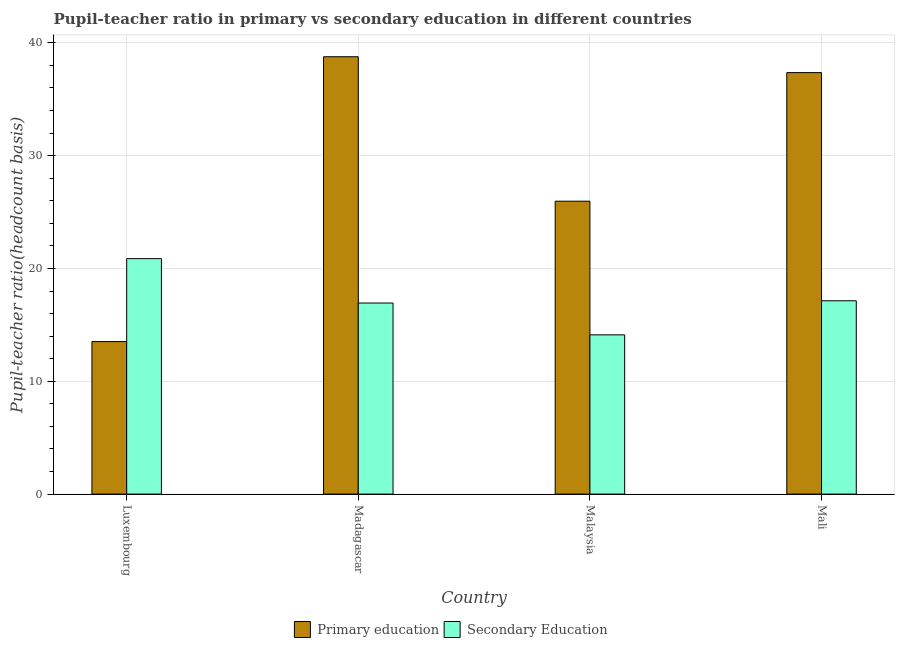How many different coloured bars are there?
Ensure brevity in your answer.  2. How many bars are there on the 1st tick from the right?
Make the answer very short. 2. What is the label of the 4th group of bars from the left?
Give a very brief answer. Mali. What is the pupil teacher ratio on secondary education in Malaysia?
Give a very brief answer. 14.11. Across all countries, what is the maximum pupil teacher ratio on secondary education?
Keep it short and to the point. 20.87. Across all countries, what is the minimum pupil-teacher ratio in primary education?
Give a very brief answer. 13.52. In which country was the pupil-teacher ratio in primary education maximum?
Offer a very short reply. Madagascar. In which country was the pupil-teacher ratio in primary education minimum?
Your answer should be very brief. Luxembourg. What is the total pupil teacher ratio on secondary education in the graph?
Provide a short and direct response. 69.05. What is the difference between the pupil-teacher ratio in primary education in Madagascar and that in Mali?
Provide a short and direct response. 1.41. What is the difference between the pupil teacher ratio on secondary education in Malaysia and the pupil-teacher ratio in primary education in Luxembourg?
Ensure brevity in your answer.  0.59. What is the average pupil-teacher ratio in primary education per country?
Your response must be concise. 28.9. What is the difference between the pupil-teacher ratio in primary education and pupil teacher ratio on secondary education in Madagascar?
Keep it short and to the point. 21.83. What is the ratio of the pupil-teacher ratio in primary education in Luxembourg to that in Mali?
Offer a very short reply. 0.36. Is the difference between the pupil-teacher ratio in primary education in Malaysia and Mali greater than the difference between the pupil teacher ratio on secondary education in Malaysia and Mali?
Ensure brevity in your answer.  No. What is the difference between the highest and the second highest pupil-teacher ratio in primary education?
Provide a succinct answer. 1.41. What is the difference between the highest and the lowest pupil-teacher ratio in primary education?
Provide a succinct answer. 25.24. What does the 2nd bar from the left in Madagascar represents?
Ensure brevity in your answer.  Secondary Education. What does the 1st bar from the right in Madagascar represents?
Your response must be concise. Secondary Education. Are all the bars in the graph horizontal?
Your response must be concise. No. What is the difference between two consecutive major ticks on the Y-axis?
Your answer should be compact. 10. Are the values on the major ticks of Y-axis written in scientific E-notation?
Keep it short and to the point. No. Does the graph contain any zero values?
Offer a terse response. No. Does the graph contain grids?
Make the answer very short. Yes. How are the legend labels stacked?
Ensure brevity in your answer.  Horizontal. What is the title of the graph?
Provide a succinct answer. Pupil-teacher ratio in primary vs secondary education in different countries. Does "Private credit bureau" appear as one of the legend labels in the graph?
Your answer should be compact. No. What is the label or title of the Y-axis?
Your answer should be very brief. Pupil-teacher ratio(headcount basis). What is the Pupil-teacher ratio(headcount basis) of Primary education in Luxembourg?
Offer a very short reply. 13.52. What is the Pupil-teacher ratio(headcount basis) in Secondary Education in Luxembourg?
Provide a succinct answer. 20.87. What is the Pupil-teacher ratio(headcount basis) in Primary education in Madagascar?
Keep it short and to the point. 38.76. What is the Pupil-teacher ratio(headcount basis) in Secondary Education in Madagascar?
Make the answer very short. 16.93. What is the Pupil-teacher ratio(headcount basis) of Primary education in Malaysia?
Ensure brevity in your answer.  25.96. What is the Pupil-teacher ratio(headcount basis) of Secondary Education in Malaysia?
Provide a short and direct response. 14.11. What is the Pupil-teacher ratio(headcount basis) of Primary education in Mali?
Give a very brief answer. 37.36. What is the Pupil-teacher ratio(headcount basis) of Secondary Education in Mali?
Make the answer very short. 17.13. Across all countries, what is the maximum Pupil-teacher ratio(headcount basis) in Primary education?
Your response must be concise. 38.76. Across all countries, what is the maximum Pupil-teacher ratio(headcount basis) of Secondary Education?
Keep it short and to the point. 20.87. Across all countries, what is the minimum Pupil-teacher ratio(headcount basis) of Primary education?
Your answer should be very brief. 13.52. Across all countries, what is the minimum Pupil-teacher ratio(headcount basis) in Secondary Education?
Keep it short and to the point. 14.11. What is the total Pupil-teacher ratio(headcount basis) of Primary education in the graph?
Provide a short and direct response. 115.6. What is the total Pupil-teacher ratio(headcount basis) in Secondary Education in the graph?
Make the answer very short. 69.05. What is the difference between the Pupil-teacher ratio(headcount basis) of Primary education in Luxembourg and that in Madagascar?
Offer a terse response. -25.24. What is the difference between the Pupil-teacher ratio(headcount basis) of Secondary Education in Luxembourg and that in Madagascar?
Offer a very short reply. 3.93. What is the difference between the Pupil-teacher ratio(headcount basis) in Primary education in Luxembourg and that in Malaysia?
Offer a terse response. -12.44. What is the difference between the Pupil-teacher ratio(headcount basis) of Secondary Education in Luxembourg and that in Malaysia?
Provide a succinct answer. 6.76. What is the difference between the Pupil-teacher ratio(headcount basis) in Primary education in Luxembourg and that in Mali?
Make the answer very short. -23.84. What is the difference between the Pupil-teacher ratio(headcount basis) in Secondary Education in Luxembourg and that in Mali?
Offer a very short reply. 3.73. What is the difference between the Pupil-teacher ratio(headcount basis) in Primary education in Madagascar and that in Malaysia?
Offer a very short reply. 12.8. What is the difference between the Pupil-teacher ratio(headcount basis) of Secondary Education in Madagascar and that in Malaysia?
Offer a terse response. 2.82. What is the difference between the Pupil-teacher ratio(headcount basis) in Primary education in Madagascar and that in Mali?
Ensure brevity in your answer.  1.41. What is the difference between the Pupil-teacher ratio(headcount basis) of Secondary Education in Madagascar and that in Mali?
Offer a terse response. -0.2. What is the difference between the Pupil-teacher ratio(headcount basis) in Primary education in Malaysia and that in Mali?
Make the answer very short. -11.39. What is the difference between the Pupil-teacher ratio(headcount basis) of Secondary Education in Malaysia and that in Mali?
Give a very brief answer. -3.02. What is the difference between the Pupil-teacher ratio(headcount basis) of Primary education in Luxembourg and the Pupil-teacher ratio(headcount basis) of Secondary Education in Madagascar?
Offer a terse response. -3.42. What is the difference between the Pupil-teacher ratio(headcount basis) of Primary education in Luxembourg and the Pupil-teacher ratio(headcount basis) of Secondary Education in Malaysia?
Give a very brief answer. -0.59. What is the difference between the Pupil-teacher ratio(headcount basis) of Primary education in Luxembourg and the Pupil-teacher ratio(headcount basis) of Secondary Education in Mali?
Your answer should be very brief. -3.62. What is the difference between the Pupil-teacher ratio(headcount basis) of Primary education in Madagascar and the Pupil-teacher ratio(headcount basis) of Secondary Education in Malaysia?
Offer a terse response. 24.65. What is the difference between the Pupil-teacher ratio(headcount basis) in Primary education in Madagascar and the Pupil-teacher ratio(headcount basis) in Secondary Education in Mali?
Keep it short and to the point. 21.63. What is the difference between the Pupil-teacher ratio(headcount basis) in Primary education in Malaysia and the Pupil-teacher ratio(headcount basis) in Secondary Education in Mali?
Your answer should be compact. 8.83. What is the average Pupil-teacher ratio(headcount basis) of Primary education per country?
Your answer should be compact. 28.9. What is the average Pupil-teacher ratio(headcount basis) of Secondary Education per country?
Make the answer very short. 17.26. What is the difference between the Pupil-teacher ratio(headcount basis) in Primary education and Pupil-teacher ratio(headcount basis) in Secondary Education in Luxembourg?
Your response must be concise. -7.35. What is the difference between the Pupil-teacher ratio(headcount basis) in Primary education and Pupil-teacher ratio(headcount basis) in Secondary Education in Madagascar?
Your answer should be compact. 21.83. What is the difference between the Pupil-teacher ratio(headcount basis) of Primary education and Pupil-teacher ratio(headcount basis) of Secondary Education in Malaysia?
Ensure brevity in your answer.  11.85. What is the difference between the Pupil-teacher ratio(headcount basis) of Primary education and Pupil-teacher ratio(headcount basis) of Secondary Education in Mali?
Your answer should be compact. 20.22. What is the ratio of the Pupil-teacher ratio(headcount basis) of Primary education in Luxembourg to that in Madagascar?
Your answer should be very brief. 0.35. What is the ratio of the Pupil-teacher ratio(headcount basis) of Secondary Education in Luxembourg to that in Madagascar?
Your response must be concise. 1.23. What is the ratio of the Pupil-teacher ratio(headcount basis) in Primary education in Luxembourg to that in Malaysia?
Offer a terse response. 0.52. What is the ratio of the Pupil-teacher ratio(headcount basis) in Secondary Education in Luxembourg to that in Malaysia?
Your response must be concise. 1.48. What is the ratio of the Pupil-teacher ratio(headcount basis) in Primary education in Luxembourg to that in Mali?
Provide a short and direct response. 0.36. What is the ratio of the Pupil-teacher ratio(headcount basis) of Secondary Education in Luxembourg to that in Mali?
Your answer should be very brief. 1.22. What is the ratio of the Pupil-teacher ratio(headcount basis) in Primary education in Madagascar to that in Malaysia?
Your answer should be compact. 1.49. What is the ratio of the Pupil-teacher ratio(headcount basis) in Secondary Education in Madagascar to that in Malaysia?
Your response must be concise. 1.2. What is the ratio of the Pupil-teacher ratio(headcount basis) of Primary education in Madagascar to that in Mali?
Your response must be concise. 1.04. What is the ratio of the Pupil-teacher ratio(headcount basis) of Secondary Education in Madagascar to that in Mali?
Your answer should be very brief. 0.99. What is the ratio of the Pupil-teacher ratio(headcount basis) of Primary education in Malaysia to that in Mali?
Your response must be concise. 0.69. What is the ratio of the Pupil-teacher ratio(headcount basis) in Secondary Education in Malaysia to that in Mali?
Your answer should be very brief. 0.82. What is the difference between the highest and the second highest Pupil-teacher ratio(headcount basis) of Primary education?
Offer a terse response. 1.41. What is the difference between the highest and the second highest Pupil-teacher ratio(headcount basis) of Secondary Education?
Make the answer very short. 3.73. What is the difference between the highest and the lowest Pupil-teacher ratio(headcount basis) of Primary education?
Your answer should be compact. 25.24. What is the difference between the highest and the lowest Pupil-teacher ratio(headcount basis) in Secondary Education?
Ensure brevity in your answer.  6.76. 